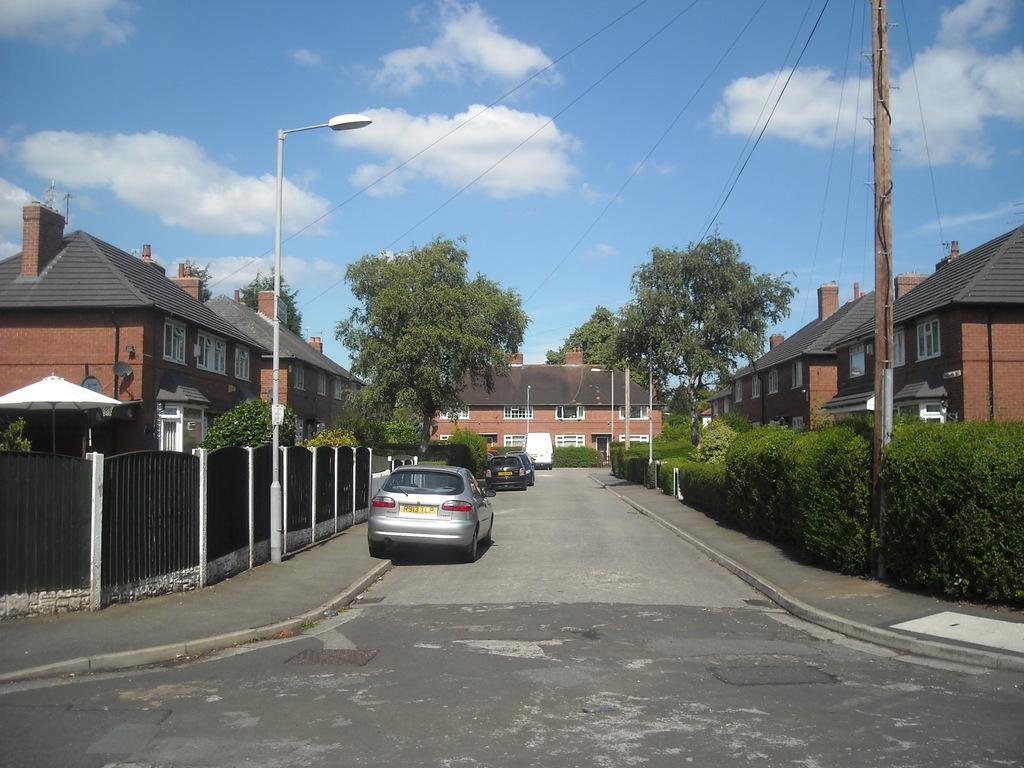Can you describe this image briefly? In the image there is a road, beside the road there are few cars parked and around the road there are plants, trees and houses. 